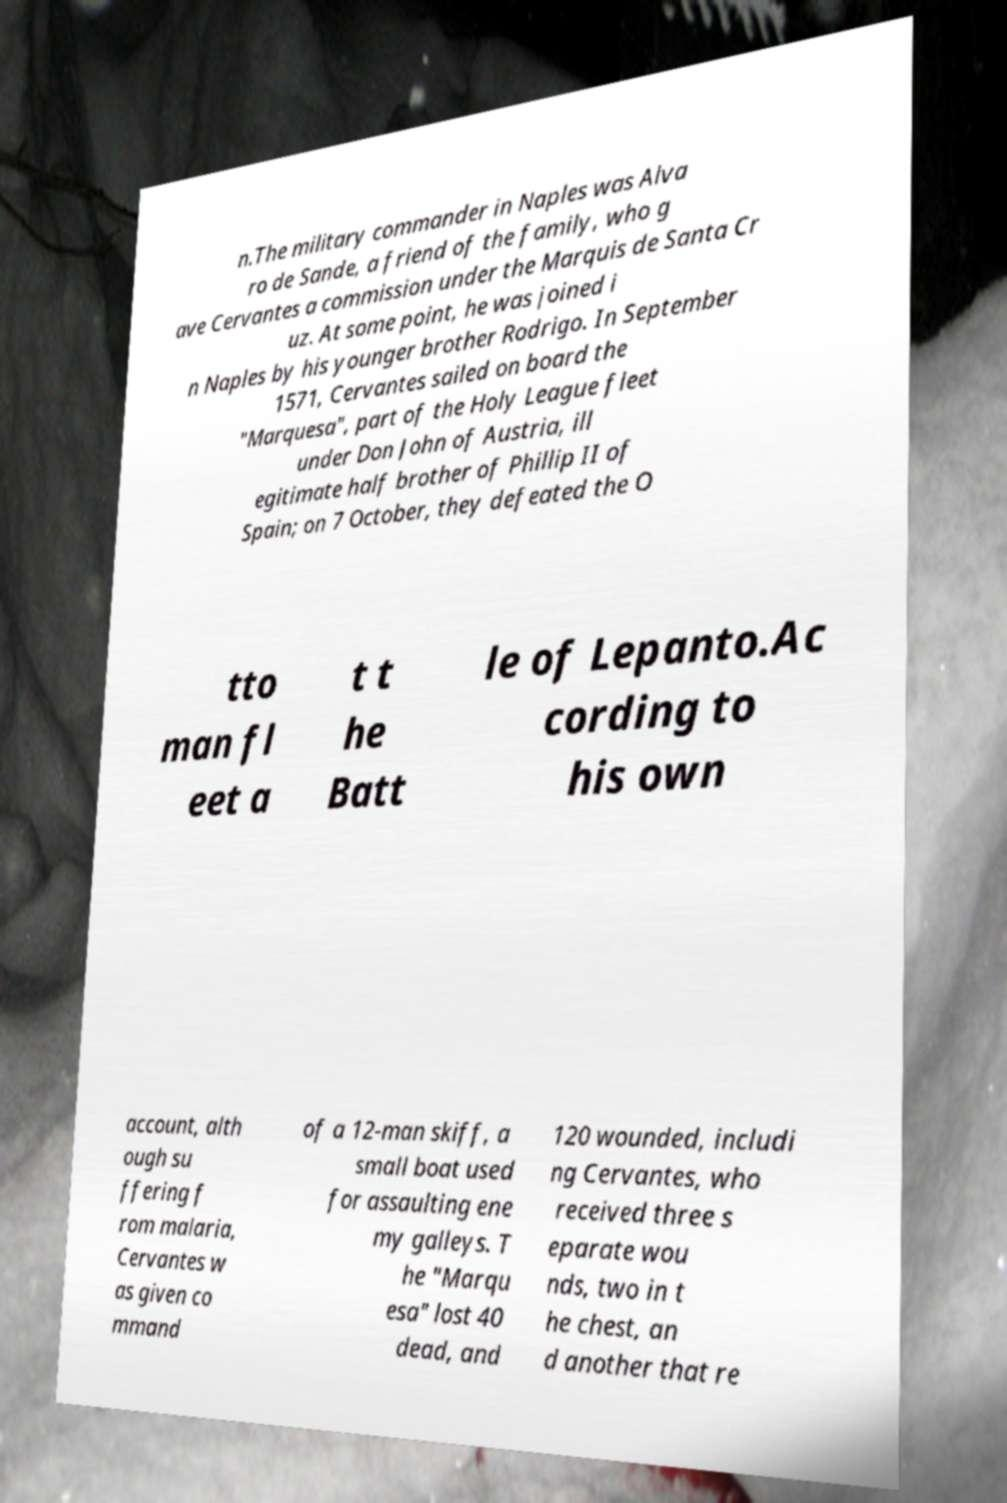Can you read and provide the text displayed in the image?This photo seems to have some interesting text. Can you extract and type it out for me? n.The military commander in Naples was Alva ro de Sande, a friend of the family, who g ave Cervantes a commission under the Marquis de Santa Cr uz. At some point, he was joined i n Naples by his younger brother Rodrigo. In September 1571, Cervantes sailed on board the "Marquesa", part of the Holy League fleet under Don John of Austria, ill egitimate half brother of Phillip II of Spain; on 7 October, they defeated the O tto man fl eet a t t he Batt le of Lepanto.Ac cording to his own account, alth ough su ffering f rom malaria, Cervantes w as given co mmand of a 12-man skiff, a small boat used for assaulting ene my galleys. T he "Marqu esa" lost 40 dead, and 120 wounded, includi ng Cervantes, who received three s eparate wou nds, two in t he chest, an d another that re 